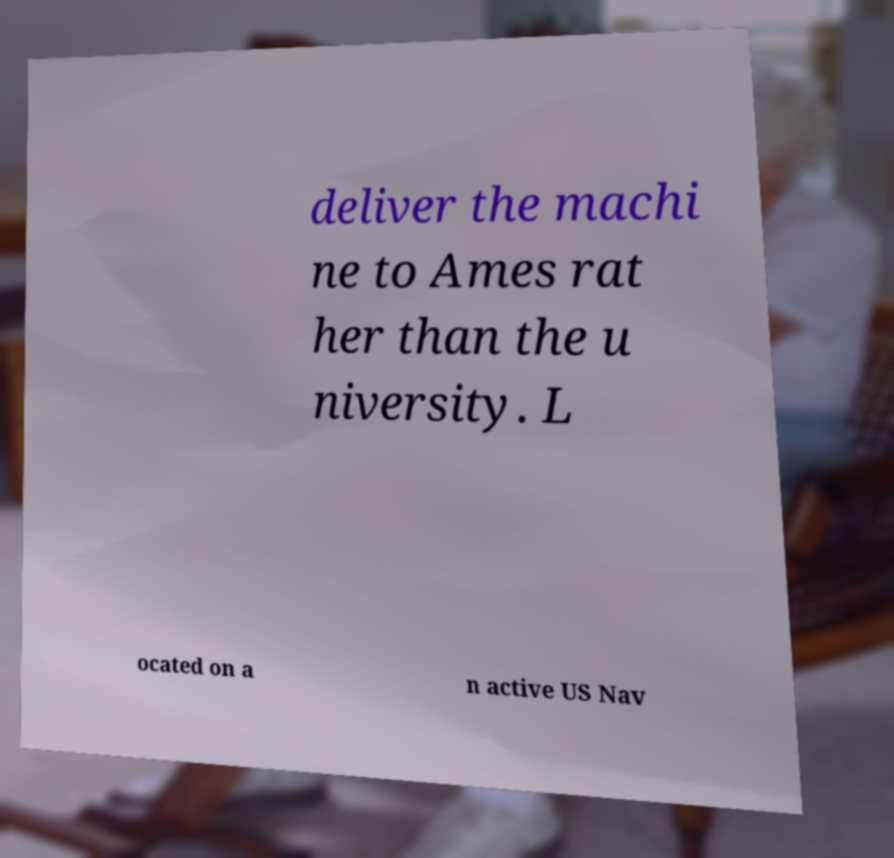Could you assist in decoding the text presented in this image and type it out clearly? deliver the machi ne to Ames rat her than the u niversity. L ocated on a n active US Nav 